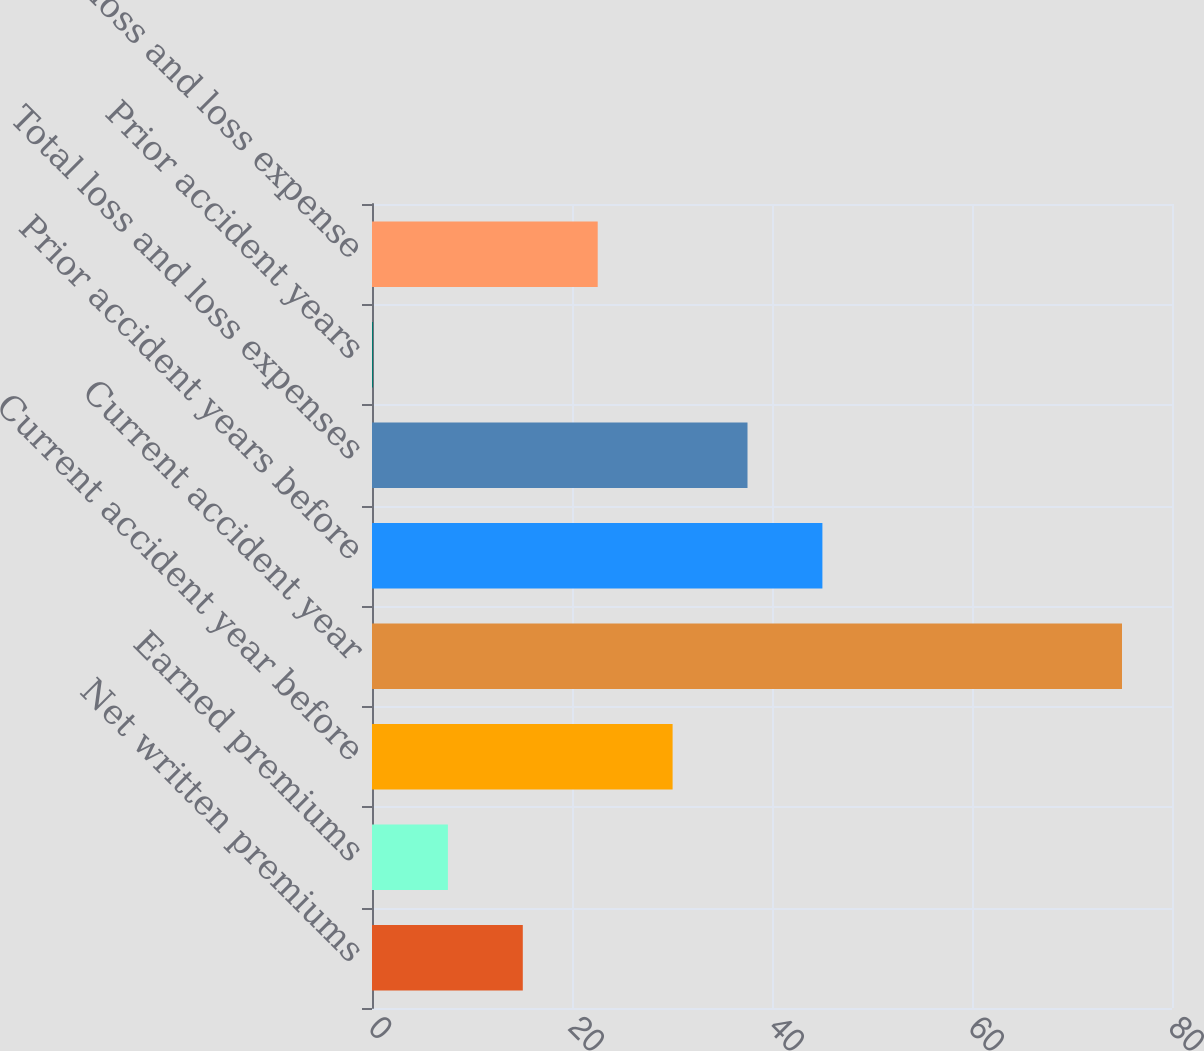Convert chart. <chart><loc_0><loc_0><loc_500><loc_500><bar_chart><fcel>Net written premiums<fcel>Earned premiums<fcel>Current accident year before<fcel>Current accident year<fcel>Prior accident years before<fcel>Total loss and loss expenses<fcel>Prior accident years<fcel>Total loss and loss expense<nl><fcel>15.08<fcel>7.59<fcel>30.06<fcel>75<fcel>45.04<fcel>37.55<fcel>0.1<fcel>22.57<nl></chart> 